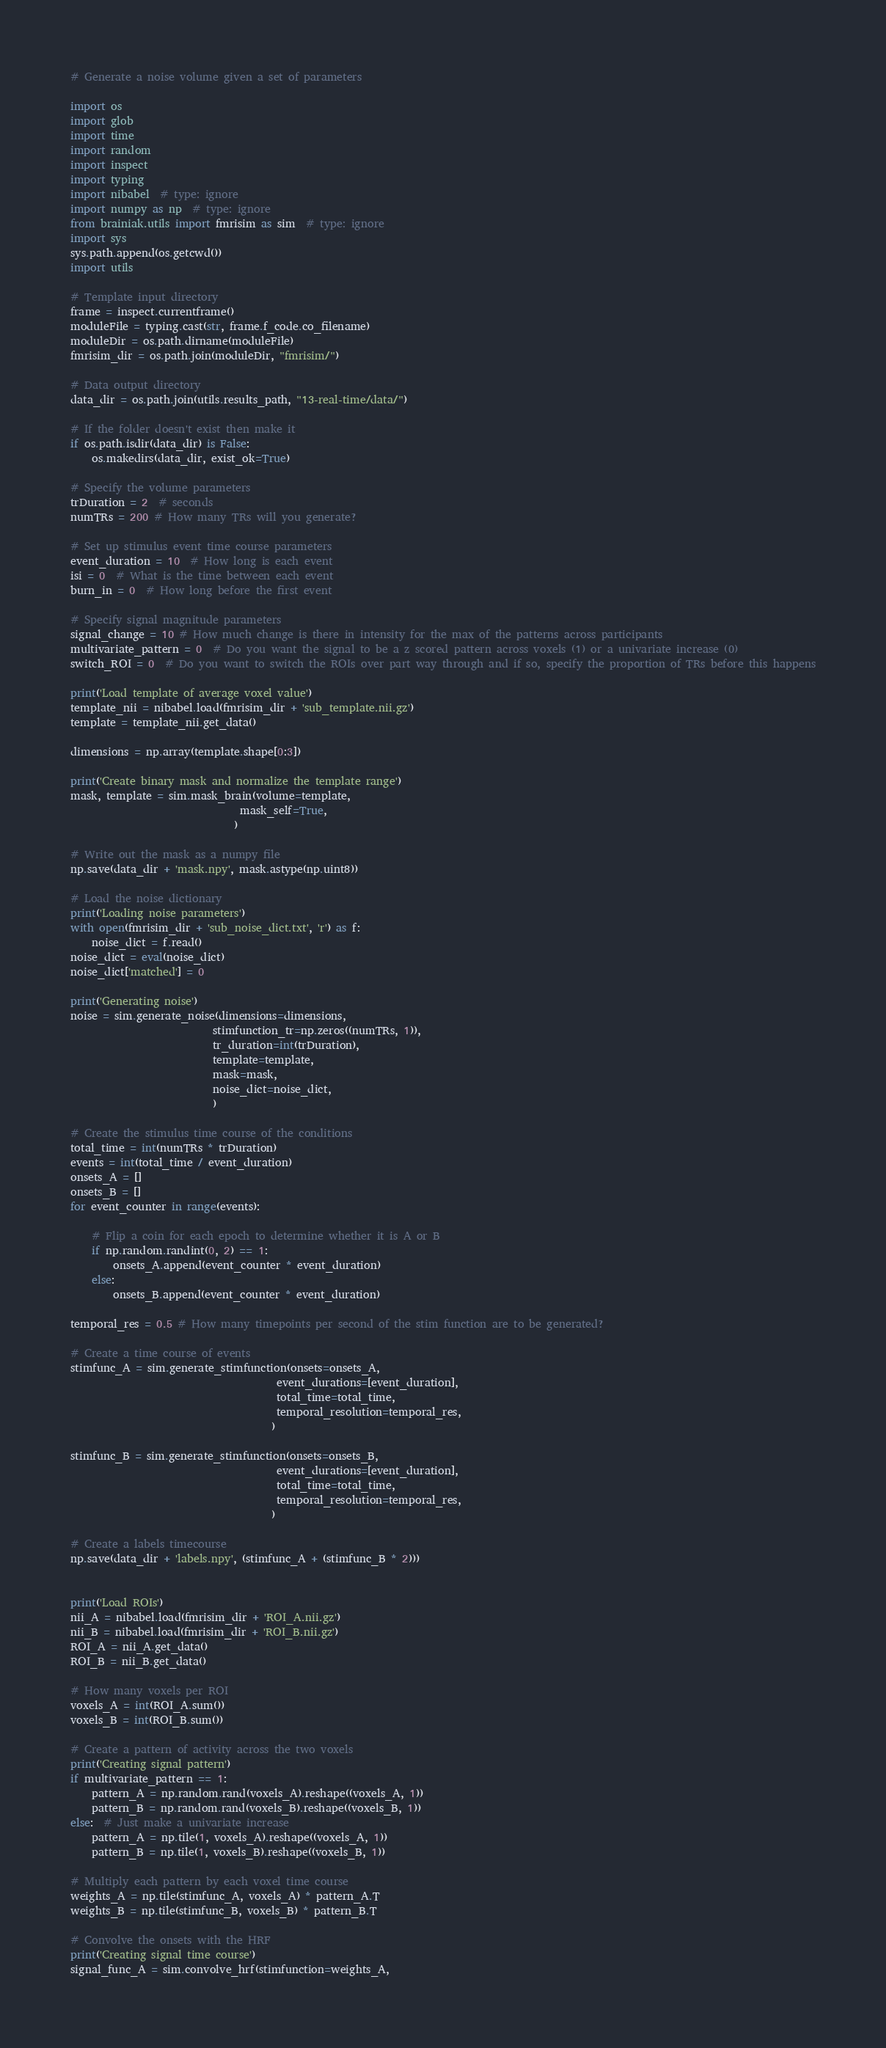<code> <loc_0><loc_0><loc_500><loc_500><_Python_># Generate a noise volume given a set of parameters

import os
import glob
import time
import random
import inspect
import typing
import nibabel  # type: ignore
import numpy as np  # type: ignore
from brainiak.utils import fmrisim as sim  # type: ignore
import sys
sys.path.append(os.getcwd())
import utils

# Template input directory
frame = inspect.currentframe()
moduleFile = typing.cast(str, frame.f_code.co_filename)
moduleDir = os.path.dirname(moduleFile)
fmrisim_dir = os.path.join(moduleDir, "fmrisim/")

# Data output directory
data_dir = os.path.join(utils.results_path, "13-real-time/data/")

# If the folder doesn't exist then make it
if os.path.isdir(data_dir) is False:
    os.makedirs(data_dir, exist_ok=True)

# Specify the volume parameters
trDuration = 2  # seconds
numTRs = 200 # How many TRs will you generate?

# Set up stimulus event time course parameters
event_duration = 10  # How long is each event
isi = 0  # What is the time between each event
burn_in = 0  # How long before the first event

# Specify signal magnitude parameters
signal_change = 10 # How much change is there in intensity for the max of the patterns across participants
multivariate_pattern = 0  # Do you want the signal to be a z scored pattern across voxels (1) or a univariate increase (0)
switch_ROI = 0  # Do you want to switch the ROIs over part way through and if so, specify the proportion of TRs before this happens

print('Load template of average voxel value')
template_nii = nibabel.load(fmrisim_dir + 'sub_template.nii.gz')
template = template_nii.get_data()

dimensions = np.array(template.shape[0:3])

print('Create binary mask and normalize the template range')
mask, template = sim.mask_brain(volume=template,
                                mask_self=True,
                               )

# Write out the mask as a numpy file
np.save(data_dir + 'mask.npy', mask.astype(np.uint8))

# Load the noise dictionary
print('Loading noise parameters')
with open(fmrisim_dir + 'sub_noise_dict.txt', 'r') as f:
    noise_dict = f.read()
noise_dict = eval(noise_dict)
noise_dict['matched'] = 0

print('Generating noise')
noise = sim.generate_noise(dimensions=dimensions,
                           stimfunction_tr=np.zeros((numTRs, 1)),
                           tr_duration=int(trDuration),
                           template=template,
                           mask=mask,
                           noise_dict=noise_dict,
                           )

# Create the stimulus time course of the conditions
total_time = int(numTRs * trDuration)
events = int(total_time / event_duration)
onsets_A = []
onsets_B = []
for event_counter in range(events):
    
    # Flip a coin for each epoch to determine whether it is A or B
    if np.random.randint(0, 2) == 1:
        onsets_A.append(event_counter * event_duration)
    else:
        onsets_B.append(event_counter * event_duration)
        
temporal_res = 0.5 # How many timepoints per second of the stim function are to be generated?

# Create a time course of events 
stimfunc_A = sim.generate_stimfunction(onsets=onsets_A,
                                       event_durations=[event_duration],
                                       total_time=total_time,
                                       temporal_resolution=temporal_res,
                                      )

stimfunc_B = sim.generate_stimfunction(onsets=onsets_B,
                                       event_durations=[event_duration],
                                       total_time=total_time,
                                       temporal_resolution=temporal_res,
                                      )

# Create a labels timecourse
np.save(data_dir + 'labels.npy', (stimfunc_A + (stimfunc_B * 2)))


print('Load ROIs')
nii_A = nibabel.load(fmrisim_dir + 'ROI_A.nii.gz')
nii_B = nibabel.load(fmrisim_dir + 'ROI_B.nii.gz')
ROI_A = nii_A.get_data()
ROI_B = nii_B.get_data()

# How many voxels per ROI
voxels_A = int(ROI_A.sum())
voxels_B = int(ROI_B.sum())

# Create a pattern of activity across the two voxels
print('Creating signal pattern')
if multivariate_pattern == 1:
    pattern_A = np.random.rand(voxels_A).reshape((voxels_A, 1))
    pattern_B = np.random.rand(voxels_B).reshape((voxels_B, 1))
else:  # Just make a univariate increase
    pattern_A = np.tile(1, voxels_A).reshape((voxels_A, 1))
    pattern_B = np.tile(1, voxels_B).reshape((voxels_B, 1))

# Multiply each pattern by each voxel time course
weights_A = np.tile(stimfunc_A, voxels_A) * pattern_A.T
weights_B = np.tile(stimfunc_B, voxels_B) * pattern_B.T

# Convolve the onsets with the HRF
print('Creating signal time course')
signal_func_A = sim.convolve_hrf(stimfunction=weights_A,</code> 